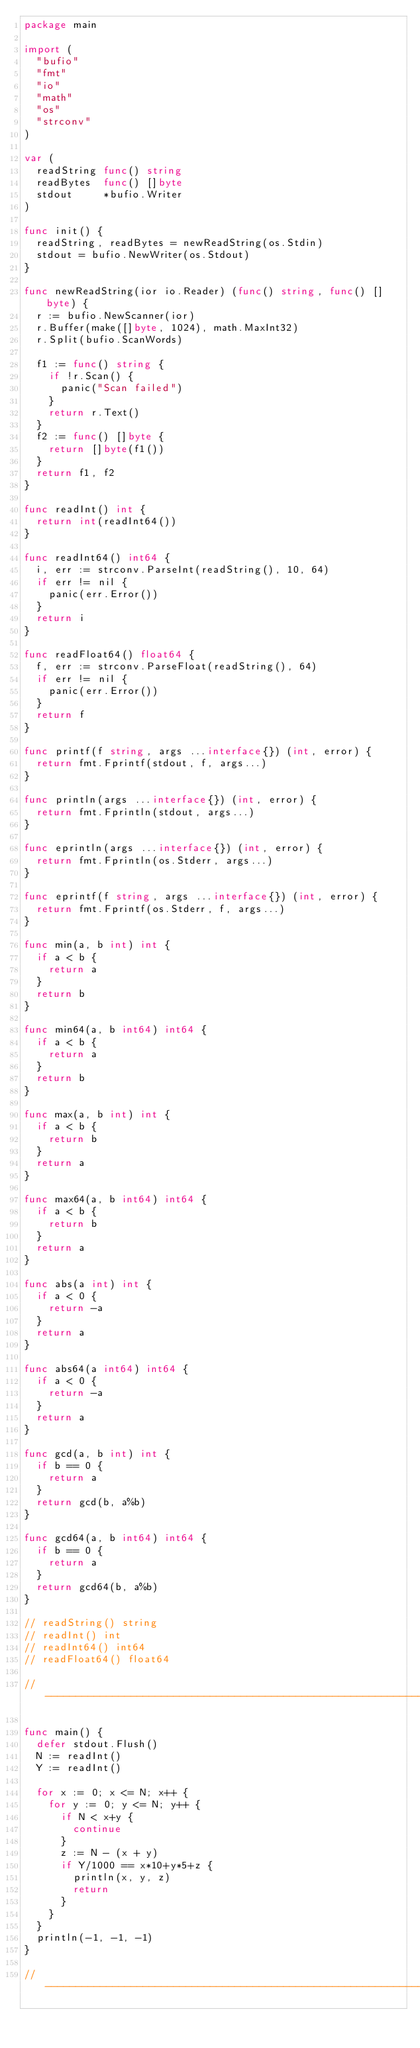Convert code to text. <code><loc_0><loc_0><loc_500><loc_500><_Go_>package main

import (
	"bufio"
	"fmt"
	"io"
	"math"
	"os"
	"strconv"
)

var (
	readString func() string
	readBytes  func() []byte
	stdout     *bufio.Writer
)

func init() {
	readString, readBytes = newReadString(os.Stdin)
	stdout = bufio.NewWriter(os.Stdout)
}

func newReadString(ior io.Reader) (func() string, func() []byte) {
	r := bufio.NewScanner(ior)
	r.Buffer(make([]byte, 1024), math.MaxInt32)
	r.Split(bufio.ScanWords)

	f1 := func() string {
		if !r.Scan() {
			panic("Scan failed")
		}
		return r.Text()
	}
	f2 := func() []byte {
		return []byte(f1())
	}
	return f1, f2
}

func readInt() int {
	return int(readInt64())
}

func readInt64() int64 {
	i, err := strconv.ParseInt(readString(), 10, 64)
	if err != nil {
		panic(err.Error())
	}
	return i
}

func readFloat64() float64 {
	f, err := strconv.ParseFloat(readString(), 64)
	if err != nil {
		panic(err.Error())
	}
	return f
}

func printf(f string, args ...interface{}) (int, error) {
	return fmt.Fprintf(stdout, f, args...)
}

func println(args ...interface{}) (int, error) {
	return fmt.Fprintln(stdout, args...)
}

func eprintln(args ...interface{}) (int, error) {
	return fmt.Fprintln(os.Stderr, args...)
}

func eprintf(f string, args ...interface{}) (int, error) {
	return fmt.Fprintf(os.Stderr, f, args...)
}

func min(a, b int) int {
	if a < b {
		return a
	}
	return b
}

func min64(a, b int64) int64 {
	if a < b {
		return a
	}
	return b
}

func max(a, b int) int {
	if a < b {
		return b
	}
	return a
}

func max64(a, b int64) int64 {
	if a < b {
		return b
	}
	return a
}

func abs(a int) int {
	if a < 0 {
		return -a
	}
	return a
}

func abs64(a int64) int64 {
	if a < 0 {
		return -a
	}
	return a
}

func gcd(a, b int) int {
	if b == 0 {
		return a
	}
	return gcd(b, a%b)
}

func gcd64(a, b int64) int64 {
	if b == 0 {
		return a
	}
	return gcd64(b, a%b)
}

// readString() string
// readInt() int
// readInt64() int64
// readFloat64() float64

// -----------------------------------------------------------------------------

func main() {
	defer stdout.Flush()
	N := readInt()
	Y := readInt()

	for x := 0; x <= N; x++ {
		for y := 0; y <= N; y++ {
			if N < x+y {
				continue
			}
			z := N - (x + y)
			if Y/1000 == x*10+y*5+z {
				println(x, y, z)
				return
			}
		}
	}
	println(-1, -1, -1)
}

// -----------------------------------------------------------------------------
</code> 